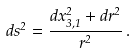Convert formula to latex. <formula><loc_0><loc_0><loc_500><loc_500>d s ^ { 2 } = \frac { d x ^ { 2 } _ { 3 , 1 } + d r ^ { 2 } } { r ^ { 2 } } \, .</formula> 